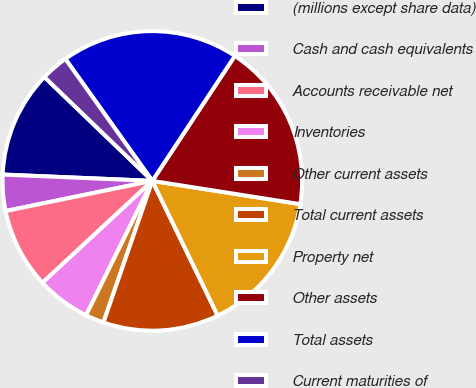<chart> <loc_0><loc_0><loc_500><loc_500><pie_chart><fcel>(millions except share data)<fcel>Cash and cash equivalents<fcel>Accounts receivable net<fcel>Inventories<fcel>Other current assets<fcel>Total current assets<fcel>Property net<fcel>Other assets<fcel>Total assets<fcel>Current maturities of<nl><fcel>11.52%<fcel>3.9%<fcel>8.67%<fcel>5.81%<fcel>2.0%<fcel>12.48%<fcel>15.33%<fcel>18.19%<fcel>19.14%<fcel>2.95%<nl></chart> 